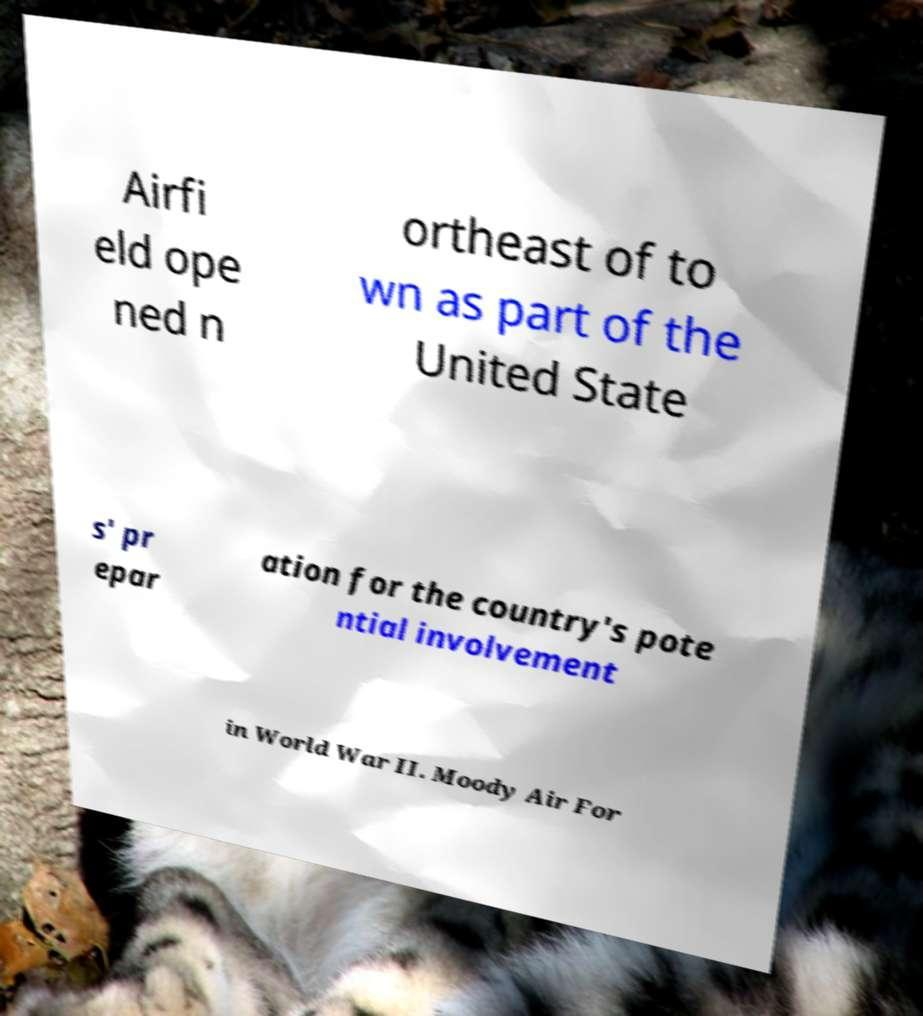Could you assist in decoding the text presented in this image and type it out clearly? Airfi eld ope ned n ortheast of to wn as part of the United State s' pr epar ation for the country's pote ntial involvement in World War II. Moody Air For 